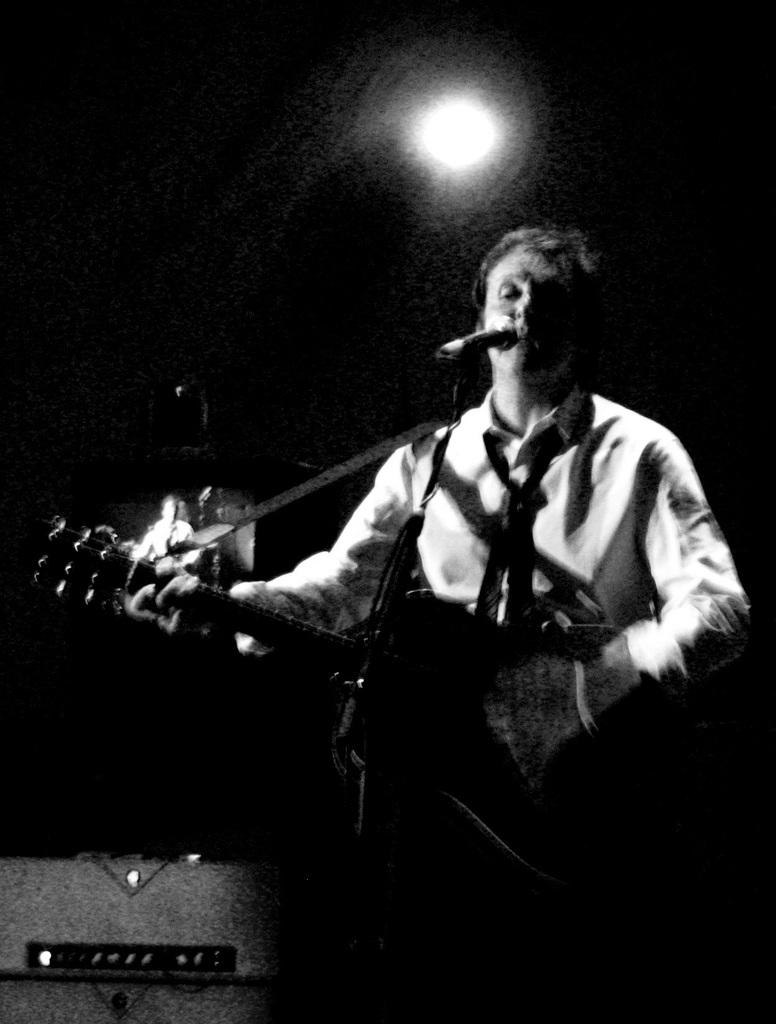What is the person in the image doing? The person is playing a guitar and singing. What object is the person in front of? The person is in front of a microphone. Can you describe the light visible in the image? There is a light visible in the image, but its specific characteristics are not mentioned. What is the person's primary activity in the image? The person's primary activity is singing and playing the guitar. What type of pen is the person using to write a song in the image? There is no pen visible in the image, and the person is not shown writing a song. 